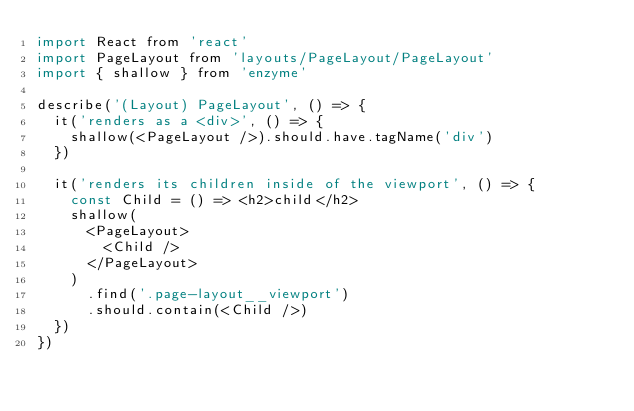Convert code to text. <code><loc_0><loc_0><loc_500><loc_500><_JavaScript_>import React from 'react'
import PageLayout from 'layouts/PageLayout/PageLayout'
import { shallow } from 'enzyme'

describe('(Layout) PageLayout', () => {
  it('renders as a <div>', () => {
    shallow(<PageLayout />).should.have.tagName('div')
  })

  it('renders its children inside of the viewport', () => {
    const Child = () => <h2>child</h2>
    shallow(
      <PageLayout>
        <Child />
      </PageLayout>
    )
      .find('.page-layout__viewport')
      .should.contain(<Child />)
  })
})
</code> 